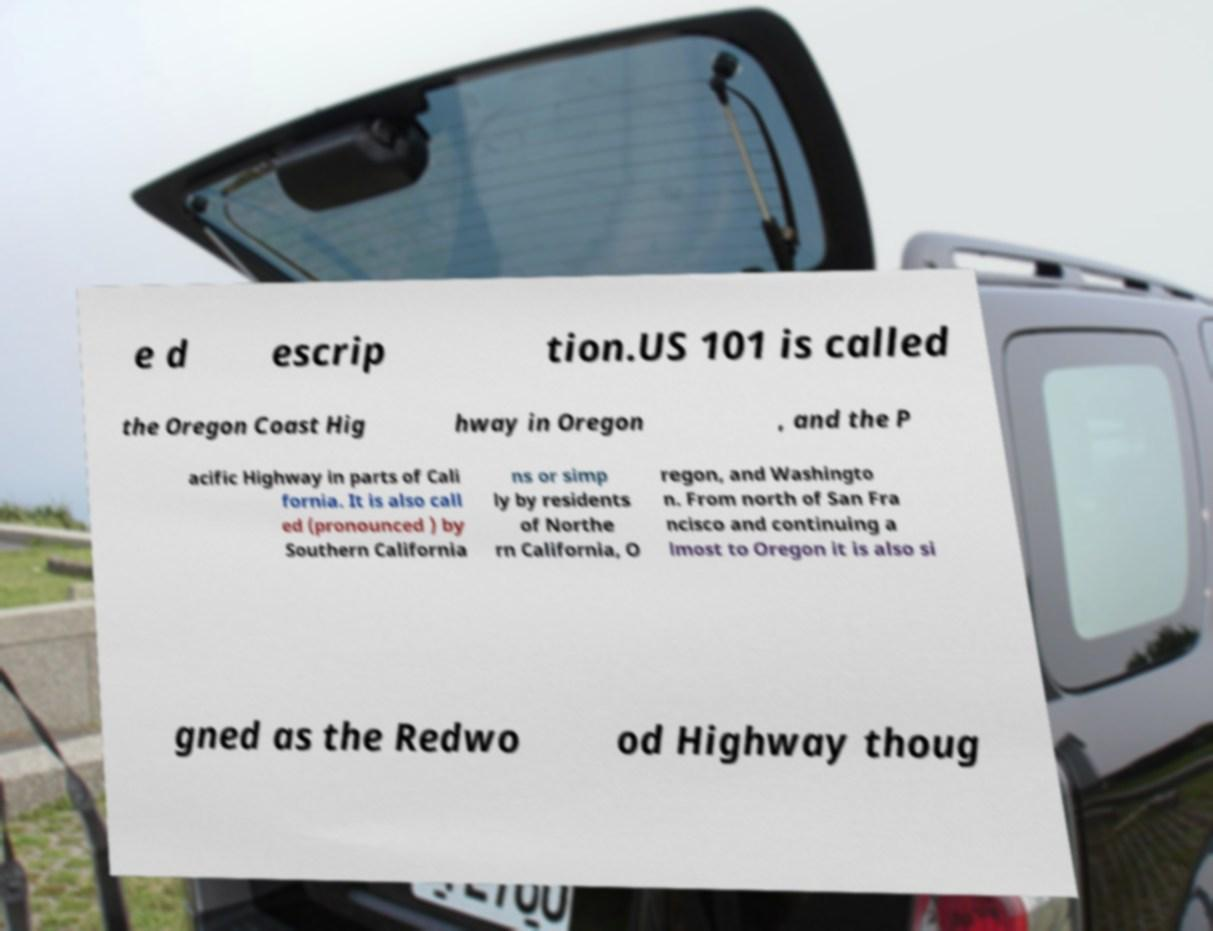For documentation purposes, I need the text within this image transcribed. Could you provide that? e d escrip tion.US 101 is called the Oregon Coast Hig hway in Oregon , and the P acific Highway in parts of Cali fornia. It is also call ed (pronounced ) by Southern California ns or simp ly by residents of Northe rn California, O regon, and Washingto n. From north of San Fra ncisco and continuing a lmost to Oregon it is also si gned as the Redwo od Highway thoug 